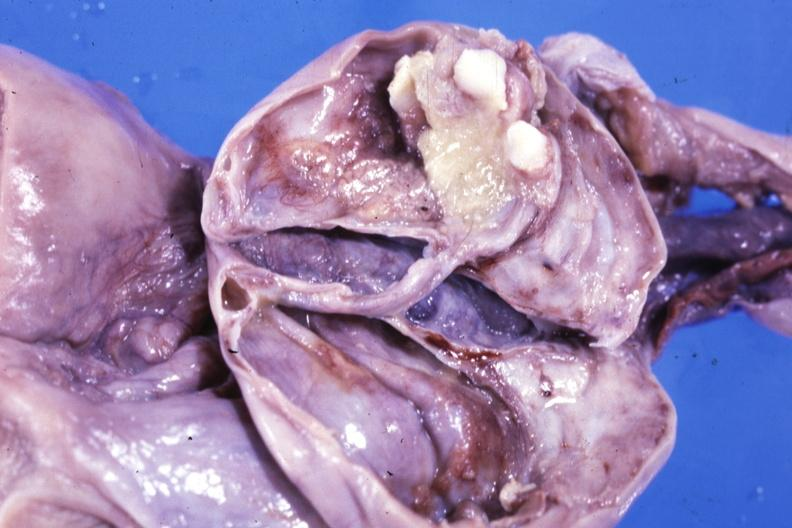does umbilical cord show fixed tissue opened ovarian cyst with two or three teeth?
Answer the question using a single word or phrase. No 